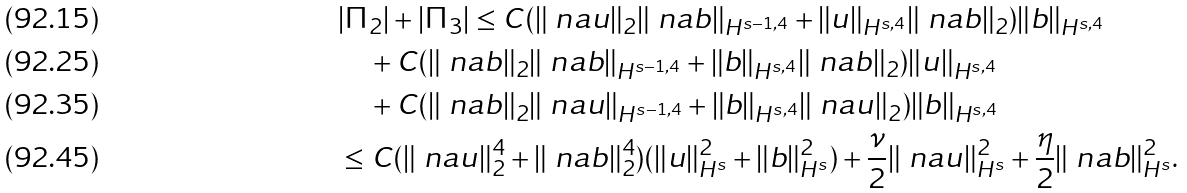<formula> <loc_0><loc_0><loc_500><loc_500>& | \Pi _ { 2 } | + | \Pi _ { 3 } | \leq C ( \| \ n a u \| _ { 2 } \| \ n a b \| _ { H ^ { s - 1 , 4 } } + \| u \| _ { H ^ { s , 4 } } \| \ n a b \| _ { 2 } ) \| b \| _ { H ^ { s , 4 } } \\ & \quad + C ( \| \ n a b \| _ { 2 } \| \ n a b \| _ { H ^ { s - 1 , 4 } } + \| b \| _ { H ^ { s , 4 } } \| \ n a b \| _ { 2 } ) \| u \| _ { H ^ { s , 4 } } \\ & \quad + C ( \| \ n a b \| _ { 2 } \| \ n a u \| _ { H ^ { s - 1 , 4 } } + \| b \| _ { H ^ { s , 4 } } \| \ n a u \| _ { 2 } ) \| b \| _ { H ^ { s , 4 } } \\ & \leq C ( \| \ n a u \| _ { 2 } ^ { 4 } + \| \ n a b \| _ { 2 } ^ { 4 } ) ( \| u \| _ { H ^ { s } } ^ { 2 } + \| b \| _ { H ^ { s } } ^ { 2 } ) + \frac { \nu } { 2 } \| \ n a u \| _ { H ^ { s } } ^ { 2 } + \frac { \eta } { 2 } \| \ n a b \| _ { H ^ { s } } ^ { 2 } .</formula> 